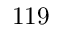<formula> <loc_0><loc_0><loc_500><loc_500>1 1 9</formula> 